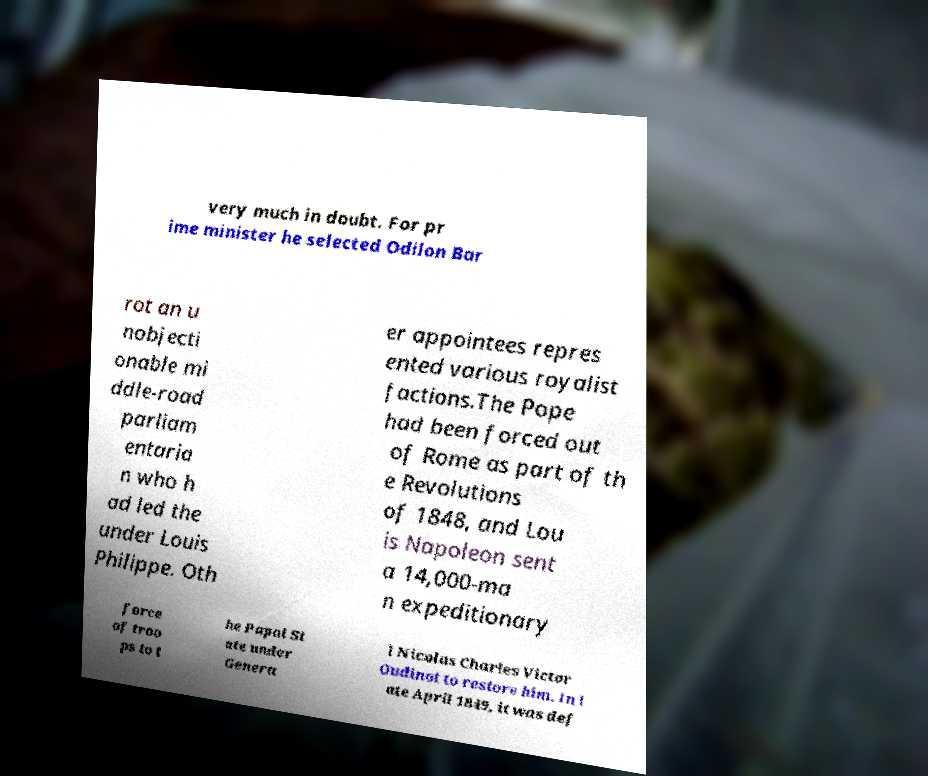Can you read and provide the text displayed in the image?This photo seems to have some interesting text. Can you extract and type it out for me? very much in doubt. For pr ime minister he selected Odilon Bar rot an u nobjecti onable mi ddle-road parliam entaria n who h ad led the under Louis Philippe. Oth er appointees repres ented various royalist factions.The Pope had been forced out of Rome as part of th e Revolutions of 1848, and Lou is Napoleon sent a 14,000-ma n expeditionary force of troo ps to t he Papal St ate under Genera l Nicolas Charles Victor Oudinot to restore him. In l ate April 1849, it was def 